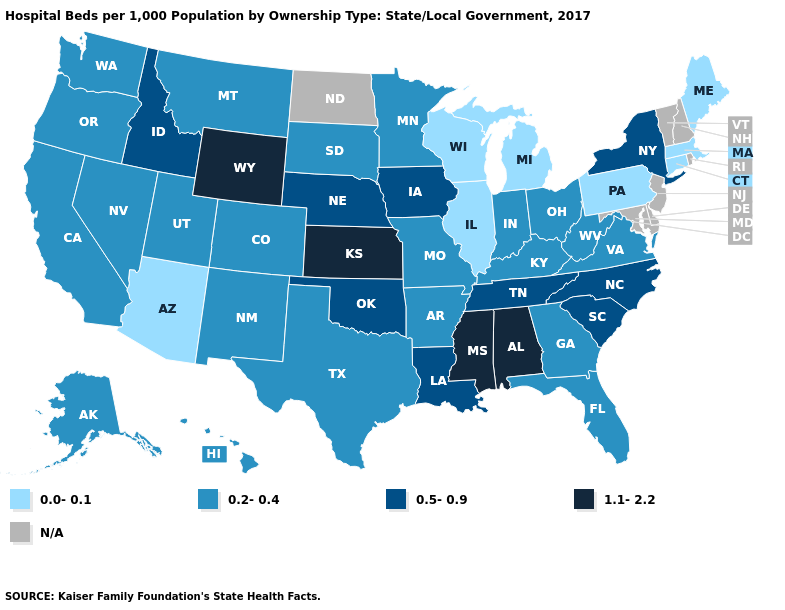Name the states that have a value in the range 0.0-0.1?
Keep it brief. Arizona, Connecticut, Illinois, Maine, Massachusetts, Michigan, Pennsylvania, Wisconsin. What is the value of Illinois?
Quick response, please. 0.0-0.1. What is the value of Ohio?
Short answer required. 0.2-0.4. Which states have the lowest value in the West?
Concise answer only. Arizona. Name the states that have a value in the range 1.1-2.2?
Short answer required. Alabama, Kansas, Mississippi, Wyoming. Which states hav the highest value in the West?
Quick response, please. Wyoming. Name the states that have a value in the range 1.1-2.2?
Be succinct. Alabama, Kansas, Mississippi, Wyoming. What is the value of Minnesota?
Short answer required. 0.2-0.4. Among the states that border Connecticut , does Massachusetts have the lowest value?
Concise answer only. Yes. Name the states that have a value in the range N/A?
Give a very brief answer. Delaware, Maryland, New Hampshire, New Jersey, North Dakota, Rhode Island, Vermont. Does Pennsylvania have the lowest value in the Northeast?
Concise answer only. Yes. Among the states that border Washington , which have the highest value?
Short answer required. Idaho. What is the highest value in the USA?
Quick response, please. 1.1-2.2. 